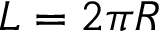<formula> <loc_0><loc_0><loc_500><loc_500>L = 2 \pi R</formula> 